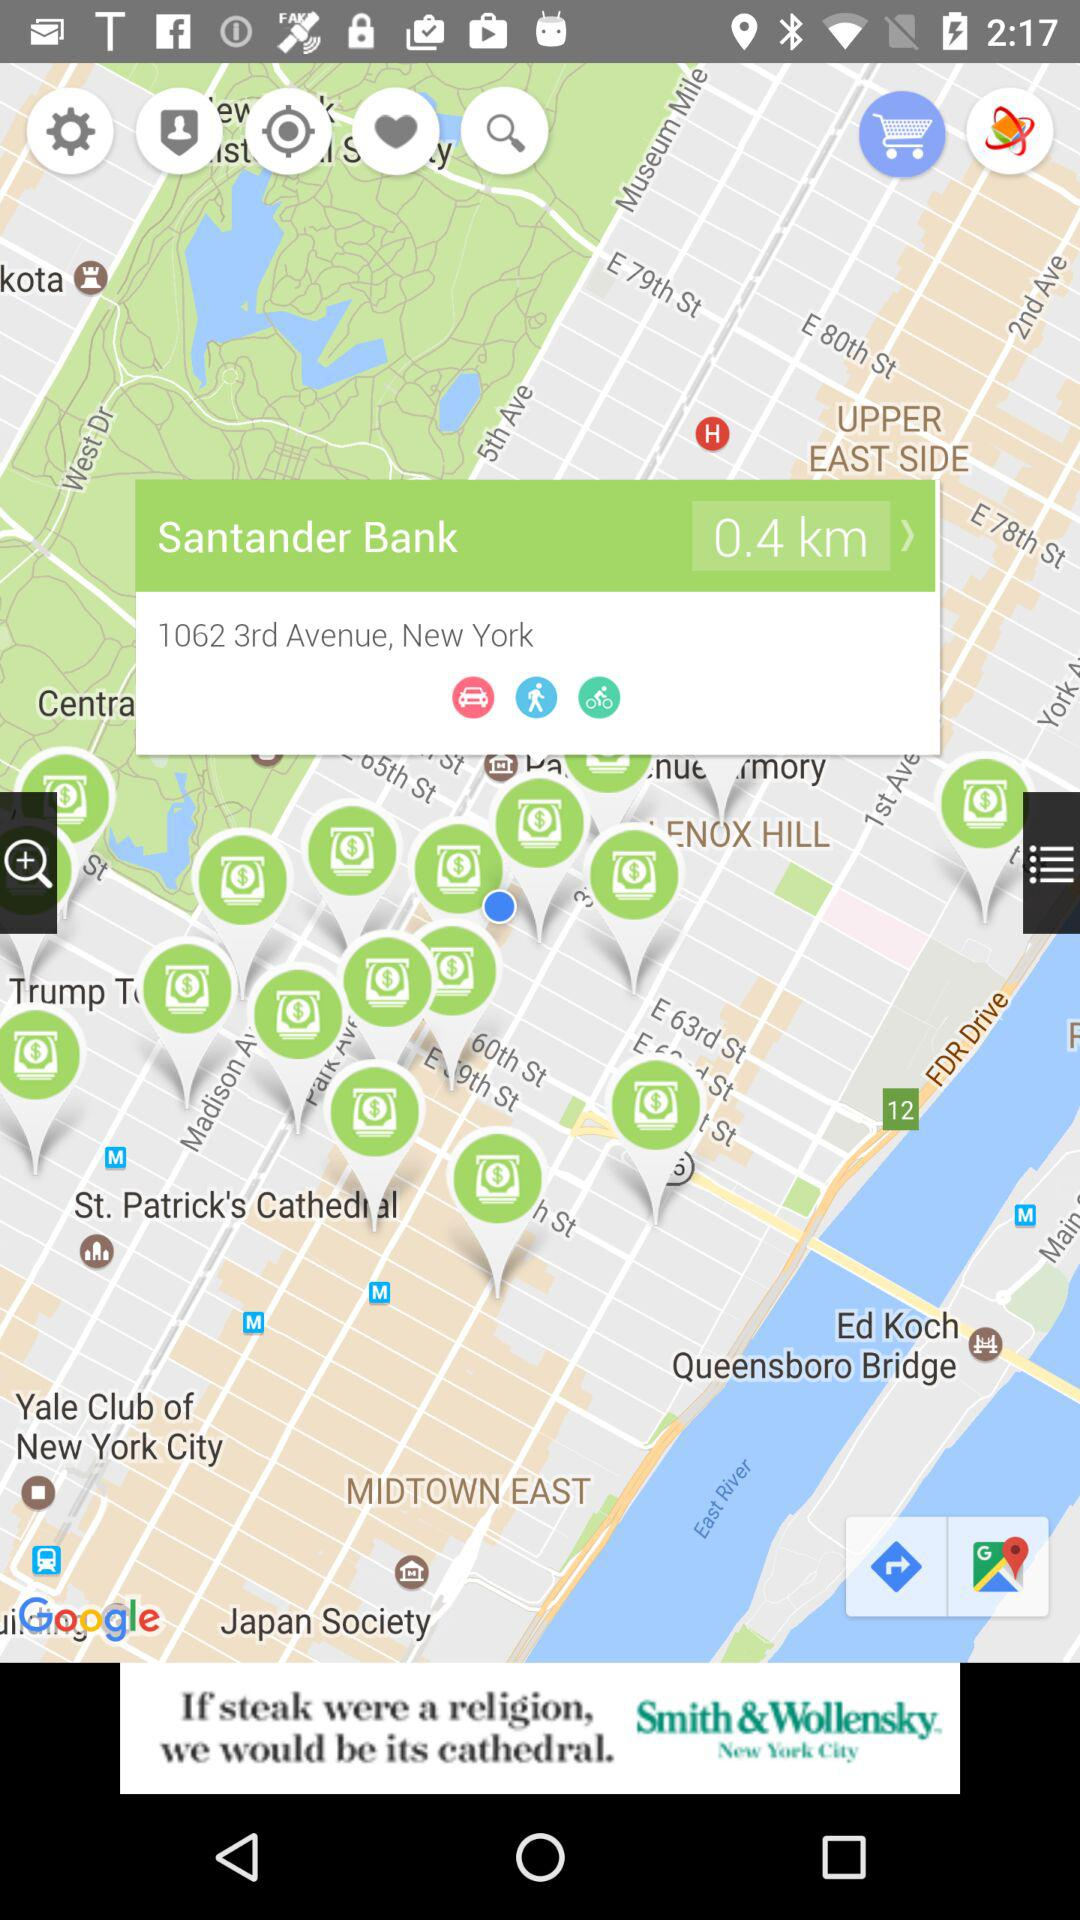How far is the "Santander Bank"? The "Santander Bank" is 0.4 kilometers away. 